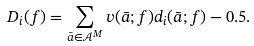<formula> <loc_0><loc_0><loc_500><loc_500>D _ { i } ( f ) = \sum _ { \bar { a } \in \mathcal { A } ^ { M } } v ( \bar { a } ; f ) d _ { i } ( \bar { a } ; f ) - 0 . 5 .</formula> 